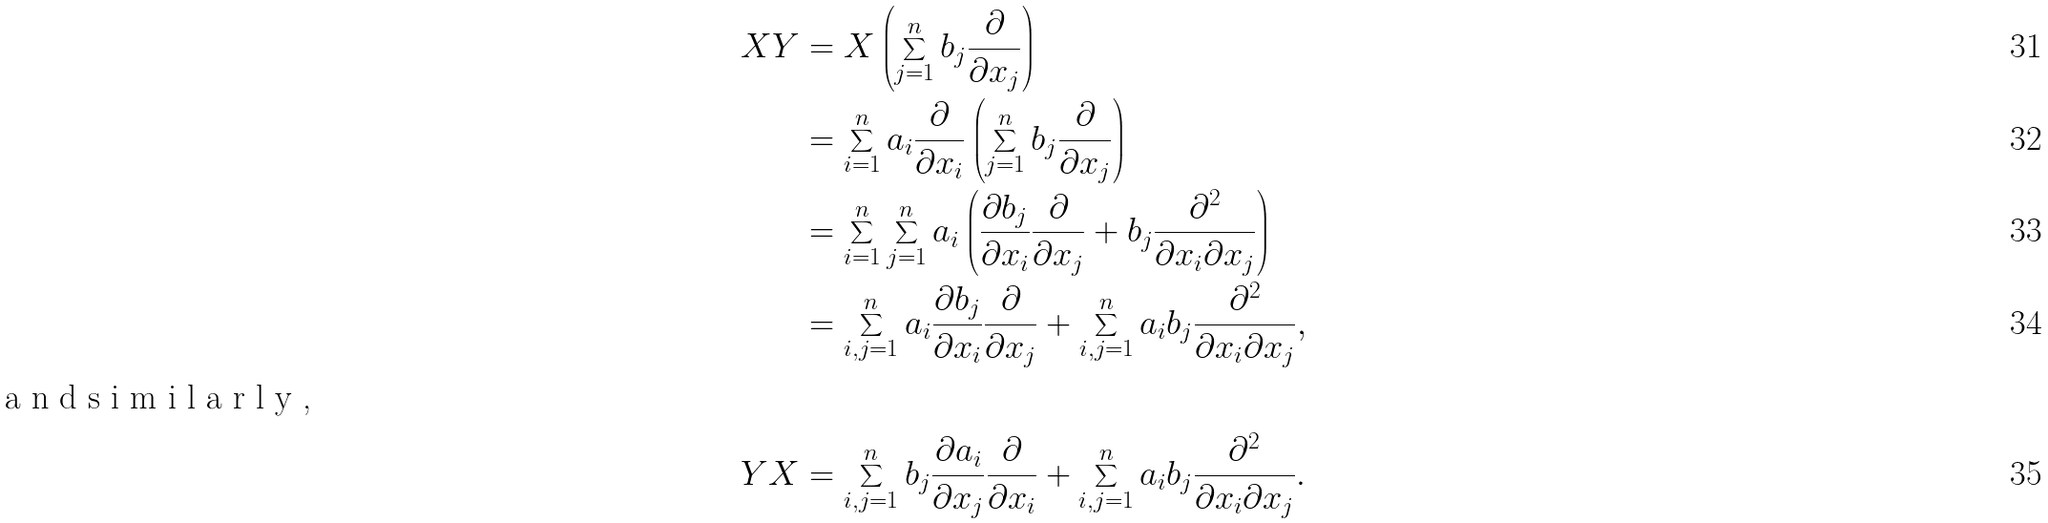<formula> <loc_0><loc_0><loc_500><loc_500>X Y & = X \left ( \sum _ { j = 1 } ^ { n } b _ { j } \frac { \partial } { \partial x _ { j } } \right ) \\ & = \sum _ { i = 1 } ^ { n } a _ { i } \frac { \partial } { \partial x _ { i } } \left ( \sum _ { j = 1 } ^ { n } b _ { j } \frac { \partial } { \partial x _ { j } } \right ) \\ & = \sum _ { i = 1 } ^ { n } \sum _ { j = 1 } ^ { n } a _ { i } \left ( \frac { \partial b _ { j } } { \partial x _ { i } } \frac { \partial } { \partial x _ { j } } + b _ { j } \frac { \partial ^ { 2 } } { \partial x _ { i } \partial x _ { j } } \right ) \\ & = \sum _ { i , j = 1 } ^ { n } a _ { i } \frac { \partial b _ { j } } { \partial x _ { i } } \frac { \partial } { \partial x _ { j } } + \sum _ { i , j = 1 } ^ { n } a _ { i } b _ { j } \frac { \partial ^ { 2 } } { \partial x _ { i } \partial x _ { j } } , \\ \intertext { a n d s i m i l a r l y , } Y X & = \sum _ { i , j = 1 } ^ { n } b _ { j } \frac { \partial a _ { i } } { \partial x _ { j } } \frac { \partial } { \partial x _ { i } } + \sum _ { i , j = 1 } ^ { n } a _ { i } b _ { j } \frac { \partial ^ { 2 } } { \partial x _ { i } \partial x _ { j } } .</formula> 